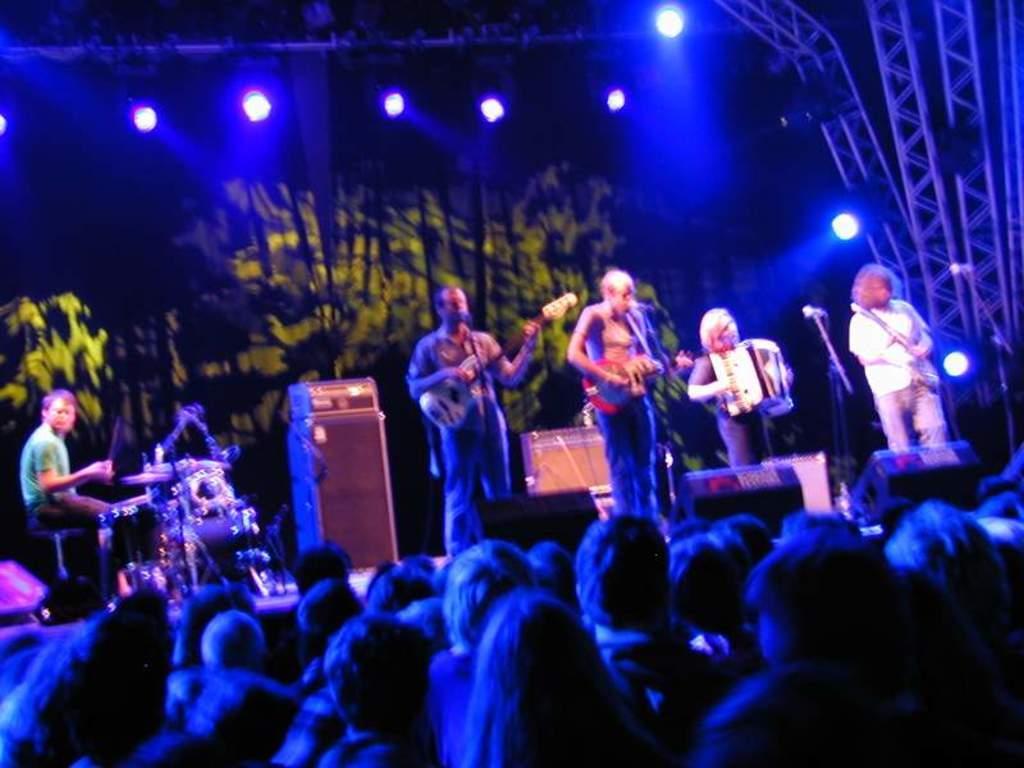In one or two sentences, can you explain what this image depicts? In this picture I can see there are few people standing on the dais and there are playing guitar and drum set and some other musical instruments and in the backdrop there is a screen and there are lights attached to the ceiling. 